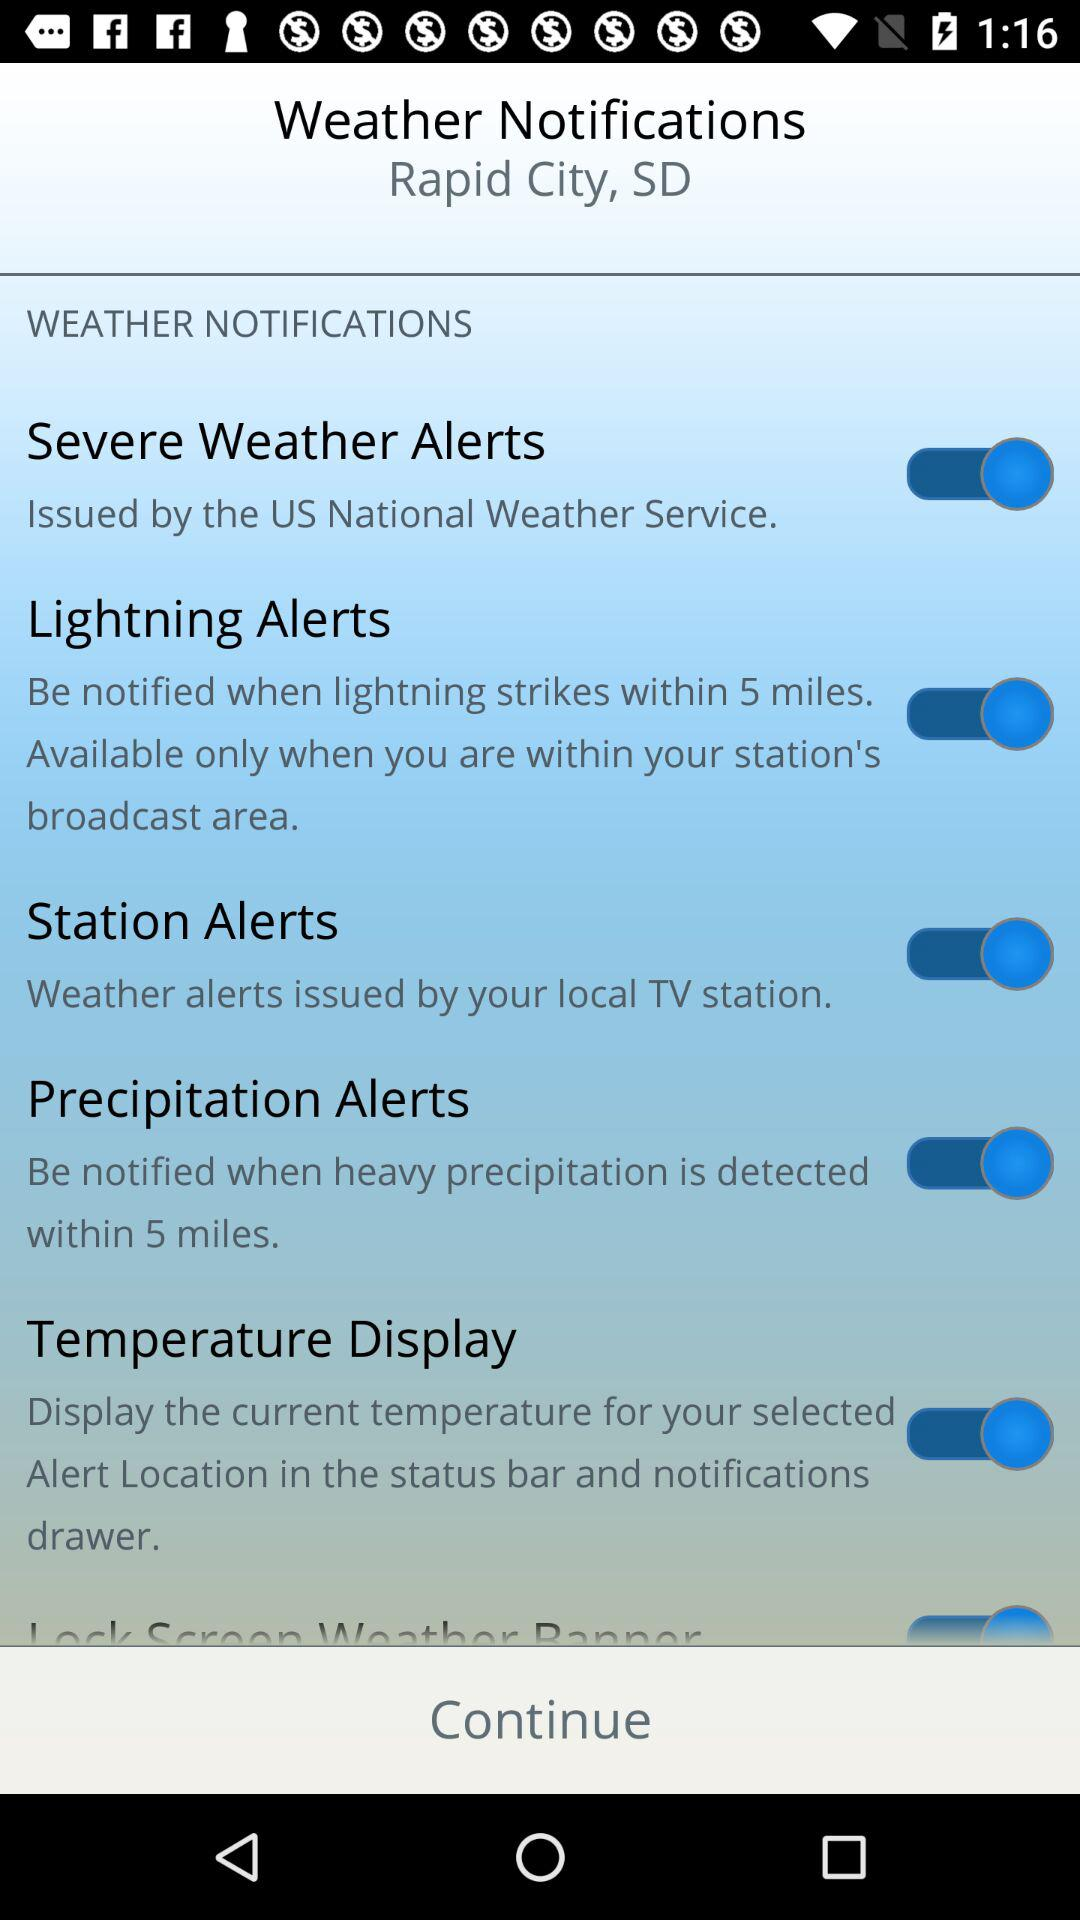How many types of alerts are available?
Answer the question using a single word or phrase. 5 